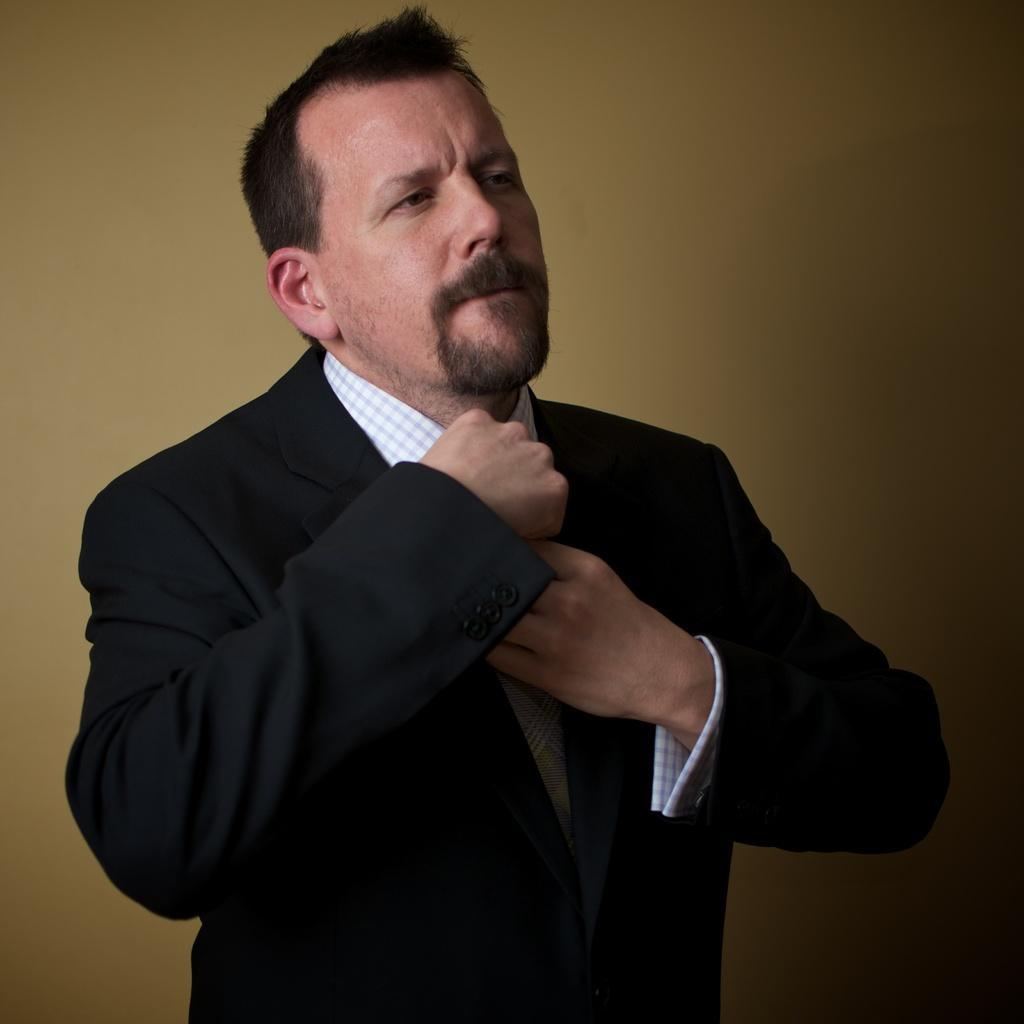In one or two sentences, can you explain what this image depicts? In this image we can see a person wearing a blazer and in the background we can see the wall. 